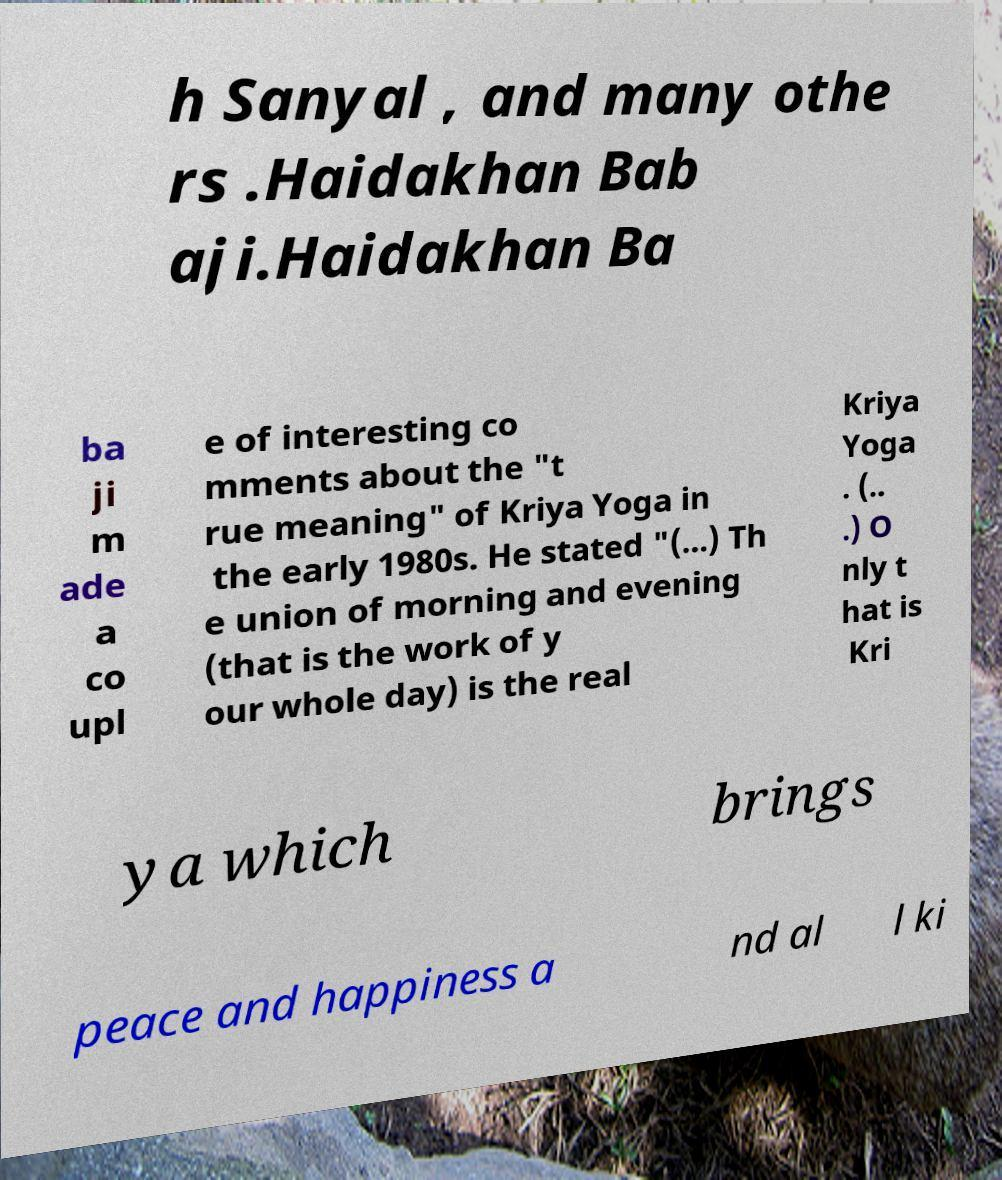There's text embedded in this image that I need extracted. Can you transcribe it verbatim? h Sanyal , and many othe rs .Haidakhan Bab aji.Haidakhan Ba ba ji m ade a co upl e of interesting co mments about the "t rue meaning" of Kriya Yoga in the early 1980s. He stated "(...) Th e union of morning and evening (that is the work of y our whole day) is the real Kriya Yoga . (.. .) O nly t hat is Kri ya which brings peace and happiness a nd al l ki 